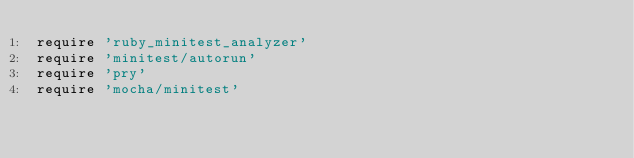Convert code to text. <code><loc_0><loc_0><loc_500><loc_500><_Ruby_>require 'ruby_minitest_analyzer'
require 'minitest/autorun'
require 'pry'
require 'mocha/minitest'
</code> 